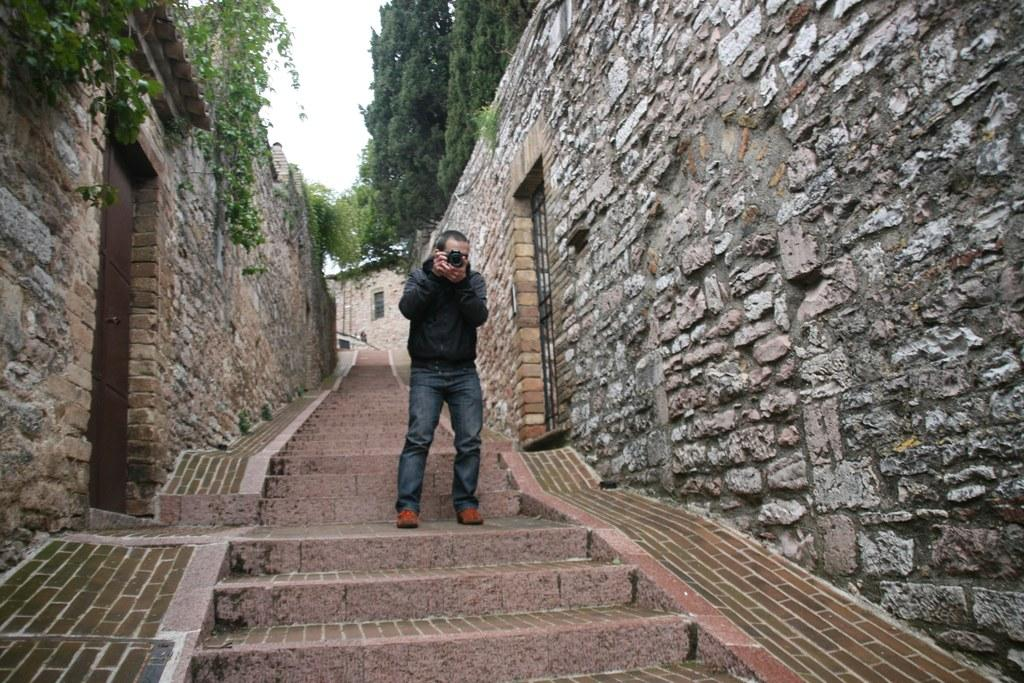What is the main subject of the image? There is a man in the image. What is the man holding in the image? The man is holding a camera with his hands. Can you describe the architectural features in the image? There are steps, walls, a door, and a window in the image. What type of natural elements can be seen in the image? There are trees and the sky visible in the image. What type of engine is visible in the image? There is no engine present in the image. How does the man select the best camera design in the image? The image does not show the man selecting a camera design; he is simply holding a camera. 